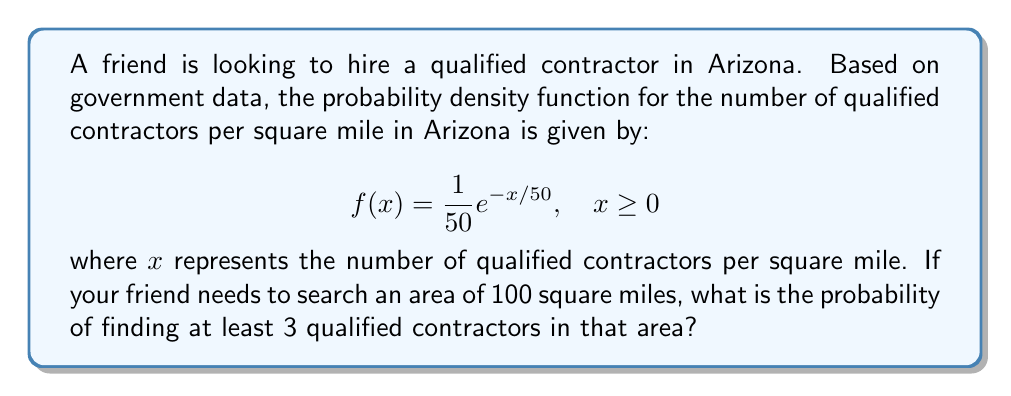Teach me how to tackle this problem. To solve this problem, we need to use integration techniques. Let's approach this step-by-step:

1) First, we need to find the probability of finding less than 3 qualified contractors in 100 square miles, then subtract this from 1 to get the probability of finding at least 3.

2) The number of contractors in 100 square miles follows a Poisson distribution with mean $\lambda = 100 \cdot E[X]$, where $E[X]$ is the expected value of the given probability density function.

3) To find $E[X]$:
   $$E[X] = \int_0^\infty x \cdot f(x) dx = \int_0^\infty x \cdot \frac{1}{50}e^{-x/50} dx$$
   
   Using integration by parts:
   $$E[X] = [-50xe^{-x/50}]_0^\infty + 50\int_0^\infty e^{-x/50} dx = 0 + 50 = 50$$

4) So, $\lambda = 100 \cdot 50 = 5000$

5) The probability of finding less than 3 contractors is:
   $$P(X < 3) = e^{-5000} + e^{-5000} \cdot 5000 + e^{-5000} \cdot \frac{5000^2}{2!}$$

6) Therefore, the probability of finding at least 3 contractors is:
   $$P(X \geq 3) = 1 - P(X < 3) = 1 - (e^{-5000} + e^{-5000} \cdot 5000 + e^{-5000} \cdot \frac{5000^2}{2!})$$

7) Calculating this (you may need a computer for precise results):
   $$P(X \geq 3) \approx 1 - 0 = 1$$
Answer: The probability of finding at least 3 qualified contractors in a 100 square mile area of Arizona is approximately 1 or 100%. 